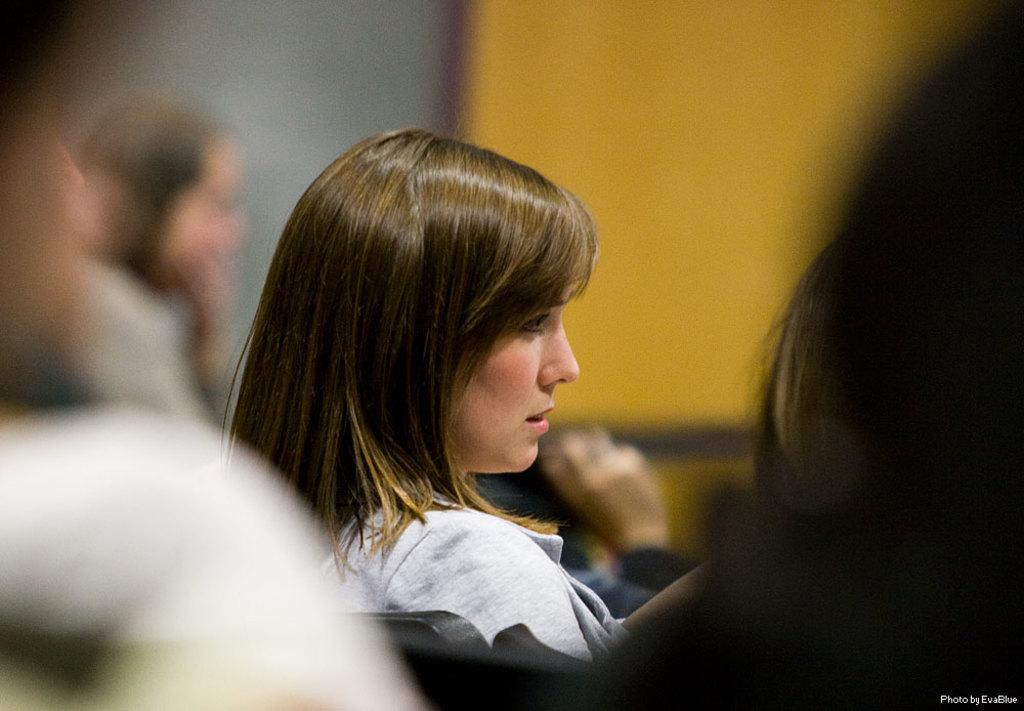Who is the main subject in the image? There is a woman in the image. What is the woman doing in the image? The woman is sitting on a chair. Are there any other people in the image? Yes, there are other people in the image. What are the other people doing in the image? The other people are standing beside the woman. What type of feather can be seen on the woman's hat in the image? There is no hat or feather visible on the woman in the image. What type of food is being served to the people in the image? There is no food visible in the image. 